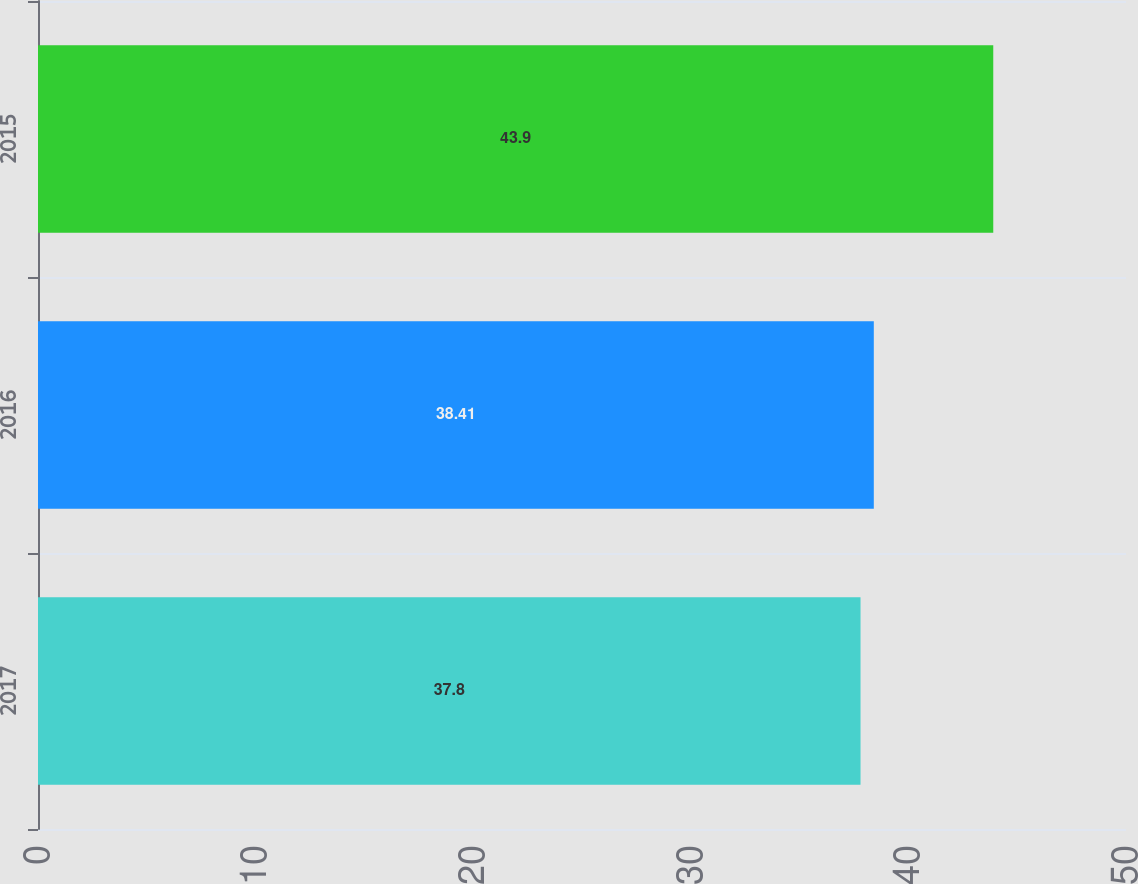<chart> <loc_0><loc_0><loc_500><loc_500><bar_chart><fcel>2017<fcel>2016<fcel>2015<nl><fcel>37.8<fcel>38.41<fcel>43.9<nl></chart> 